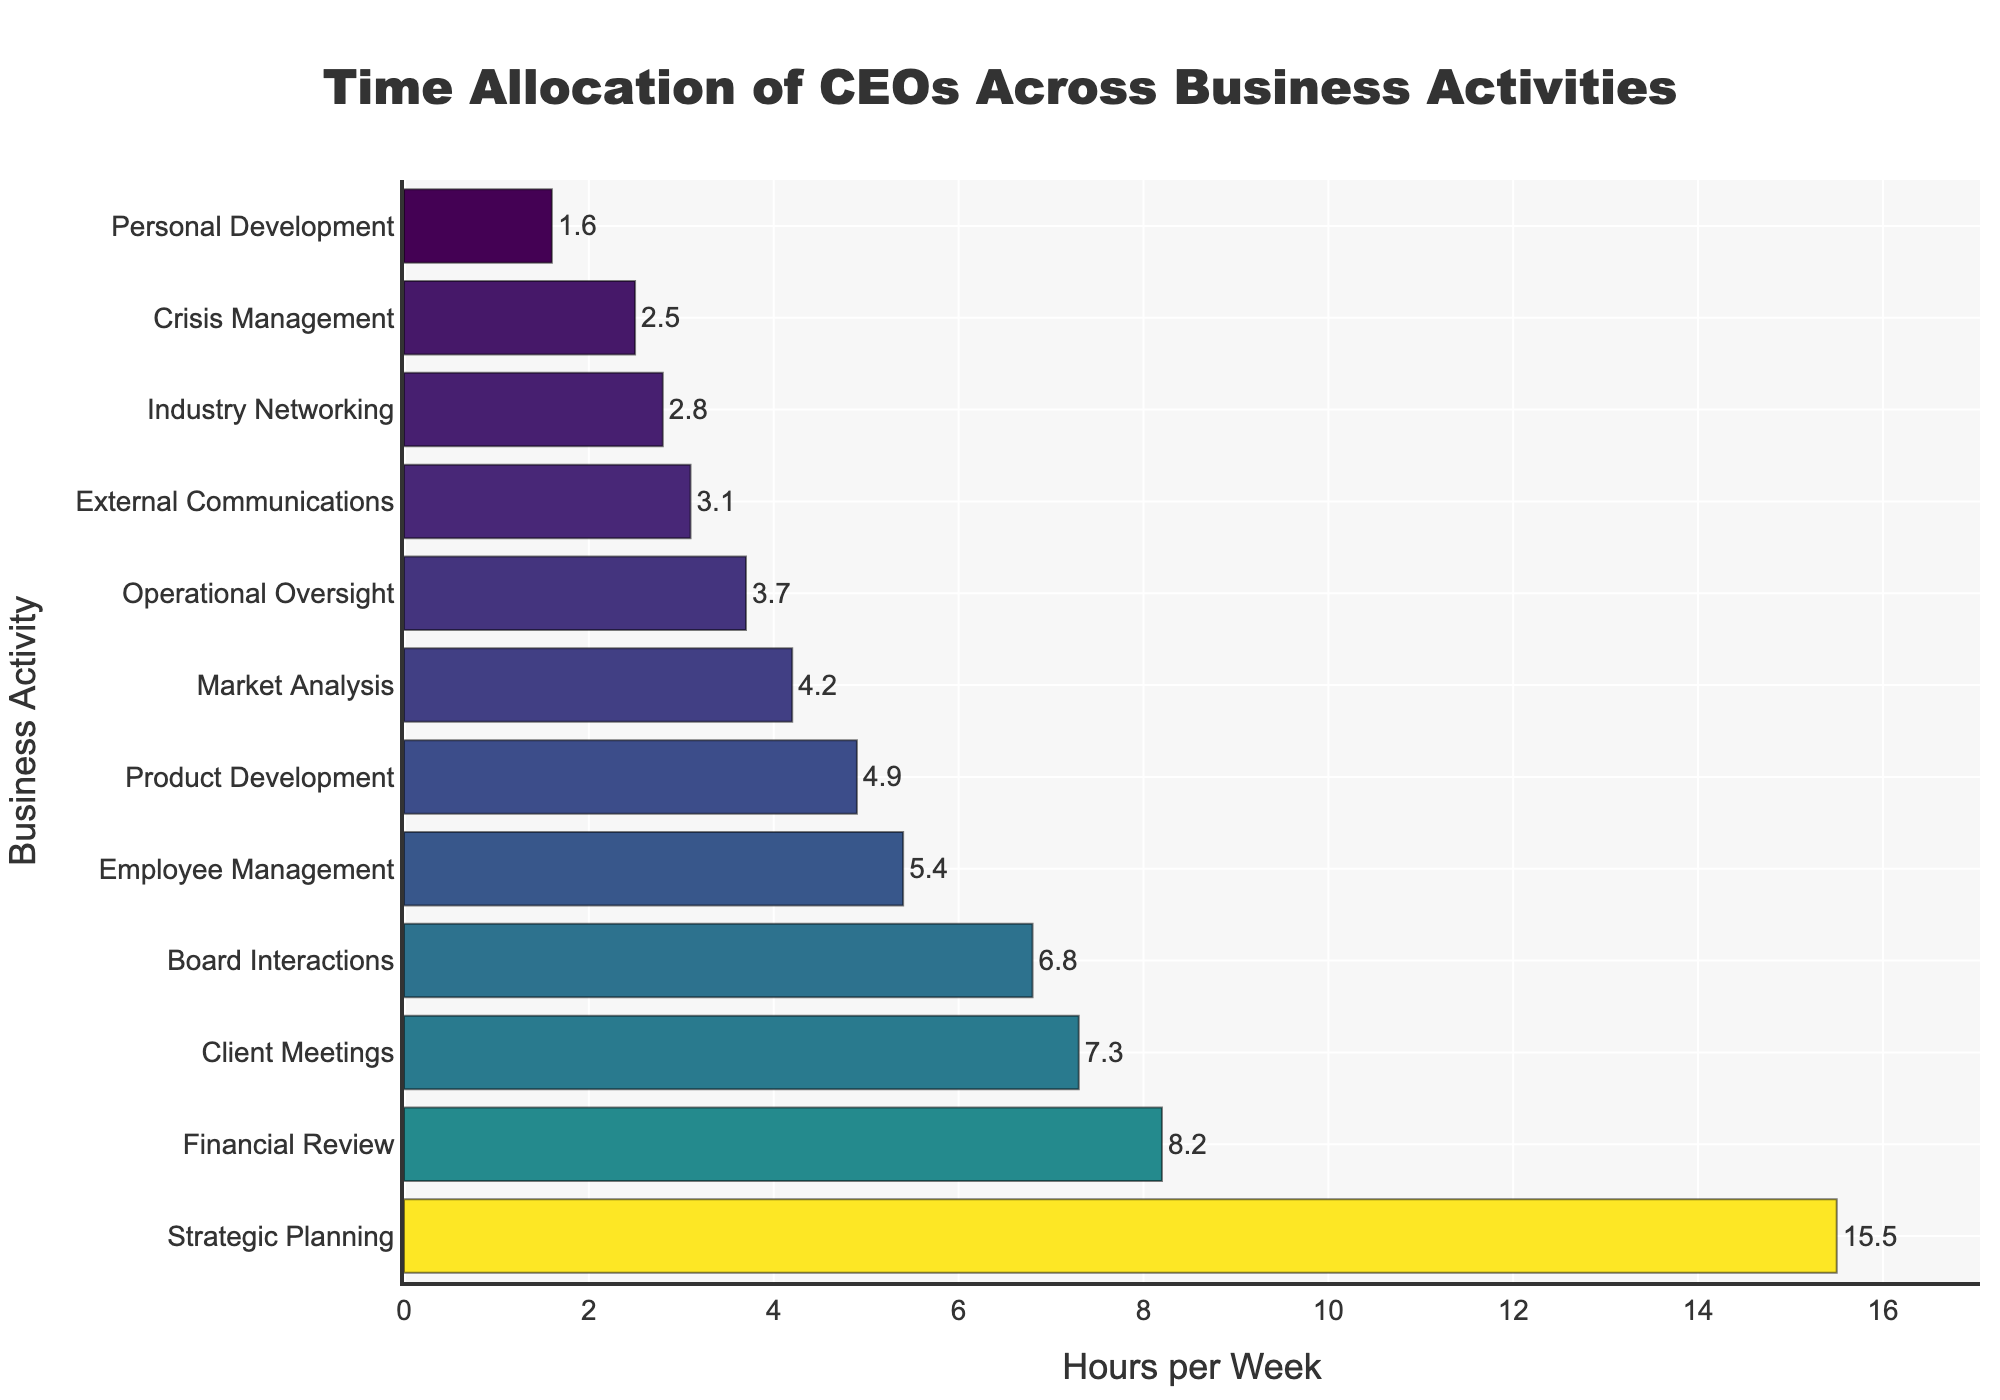What's the most time-consuming activity for CEOs? To find out the most time-consuming activity, look for the bar with the greatest length. The figure shows that "Strategic Planning" has the longest bar.
Answer: Strategic Planning Compare the time spent on Financial Review and Product Development. Which one takes more hours, and by how much? Observe the length of the bars for both activities and read the corresponding hours. Financial Review is 8.2 hours, and Product Development is 4.9 hours. Subtract the smaller value from the larger value: 8.2 - 4.9.
Answer: Financial Review by 3.3 hours What is the combined time CEOs spend on Board Interactions and Client Meetings? Find the hours for both activities from the bars: Board Interactions (6.8 hours) and Client Meetings (7.3 hours). Add these values together: 6.8 + 7.3.
Answer: 14.1 hours How does the time allocated to Employee Management compare to Market Analysis? Check the lengths of the bars for these two activities. Employee Management is at 5.4 hours, and Market Analysis is at 4.2 hours. Compare these values directly.
Answer: Employee Management takes 1.2 more hours What activities take less than 3 hours per week on average? Look for bars with lengths corresponding to hours less than 3. The activities that fall in this range are External Communications (3.1 hours just slightly above), Industry Networking (2.8 hours), Crisis Management (2.5 hours), and Personal Development (1.6 hours).
Answer: Industry Networking, Crisis Management, Personal Development What is the average time spent on External Communications, Industry Networking, and Crisis Management? Add the hours for these three activities: External Communications (3.1), Industry Networking (2.8), Crisis Management (2.5). Then divide by the number of activities: (3.1 + 2.8 + 2.5) / 3
Answer: 2.8 hours Which activities are assigned more time than Market Analysis but less than Financial Review? Identify the hours for Market Analysis (4.2 hours) and Financial Review (8.2 hours). Activities with hours within this range are Product Development (4.9), Employee Management (5.4), Board Interactions (6.8), and Client Meetings (7.3).
Answer: Product Development, Employee Management, Board Interactions, Client Meetings How much more time is dedicated to Strategic Planning compared to Crisis Management? Look at the hours for Strategic Planning (15.5 hours) and Crisis Management (2.5 hours). Subtract the smaller value from the larger one: 15.5 - 2.5.
Answer: 13 hours What is the median value of time allocation for the listed activities? To find the median, first rank the hours in ascending order. The values are: 1.6, 2.5, 2.8, 3.1, 3.7, 4.2, 4.9, 5.4, 6.8, 7.3, 8.2, 15.5. The median is the middle value in an ordered list, or the average of the two middle values. Here the middle two values are 4.2 and 4.9, so (4.2 + 4.9)/2.
Answer: 4.55 hours Are there any activities with equal time allocation? Scan the lengths of the bars and corresponding hours. There are no activities with the same amount of hours allocated in the chart.
Answer: No 